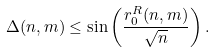Convert formula to latex. <formula><loc_0><loc_0><loc_500><loc_500>\Delta ( n , m ) \leq \sin \left ( \frac { r _ { 0 } ^ { R } ( n , m ) } { \sqrt { n } } \right ) .</formula> 